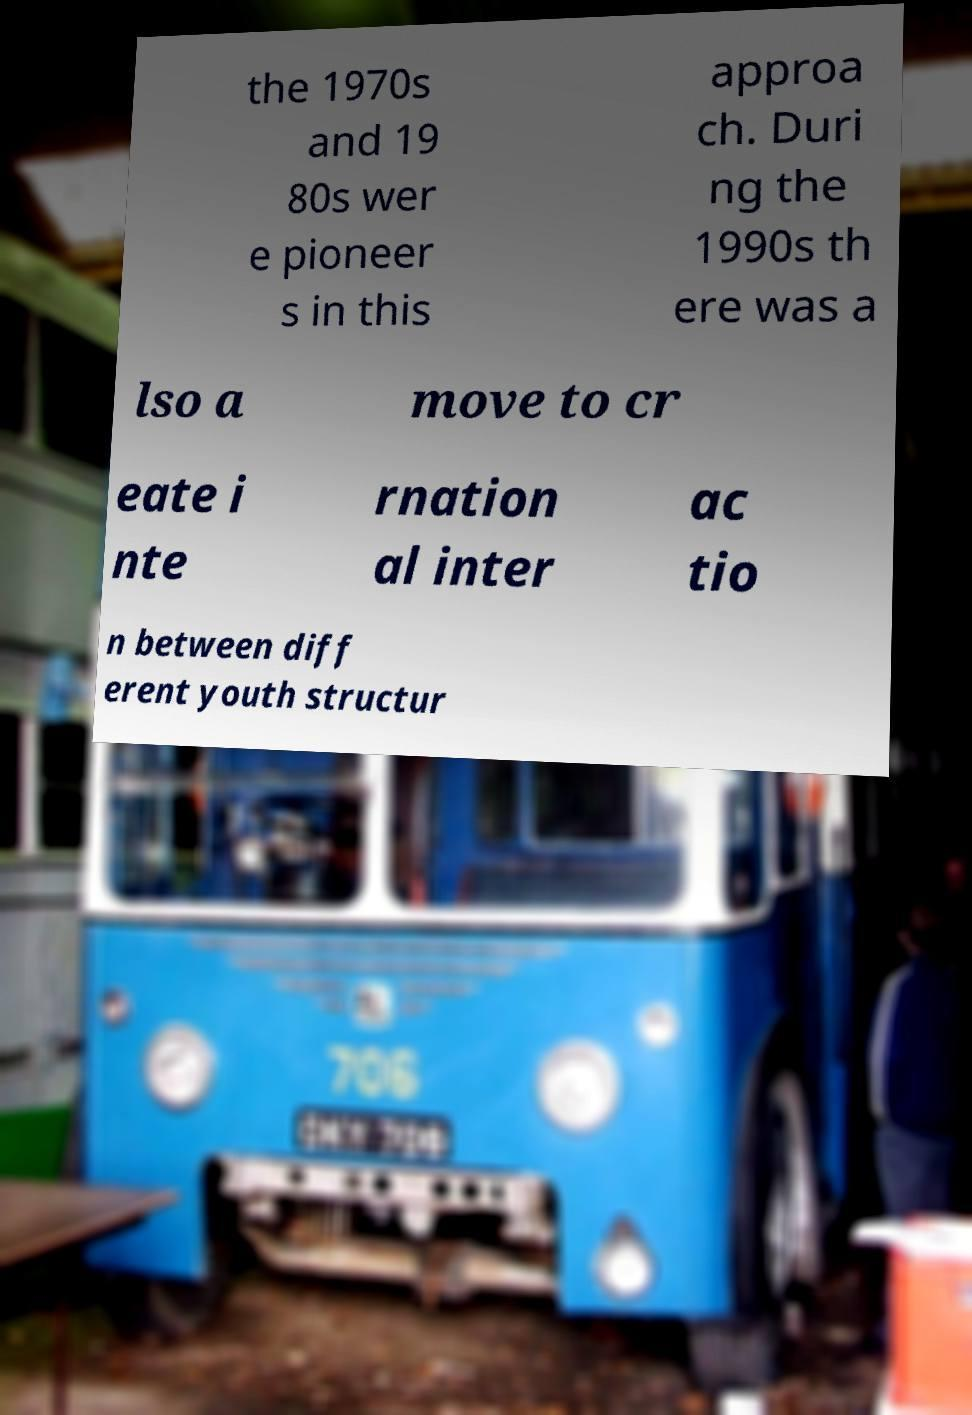Can you accurately transcribe the text from the provided image for me? the 1970s and 19 80s wer e pioneer s in this approa ch. Duri ng the 1990s th ere was a lso a move to cr eate i nte rnation al inter ac tio n between diff erent youth structur 